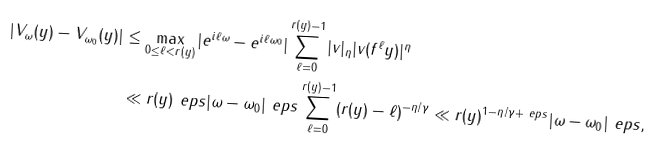<formula> <loc_0><loc_0><loc_500><loc_500>| V _ { \omega } ( y ) - V _ { \omega _ { 0 } } ( y ) | & \leq \max _ { 0 \leq \ell < r ( y ) } | e ^ { i \ell \omega } - e ^ { i \ell \omega _ { 0 } } | \sum _ { \ell = 0 } ^ { r ( y ) - 1 } | v | _ { \eta } | v ( f ^ { \ell } y ) | ^ { \eta } \\ & \ll r ( y ) ^ { \ } e p s | \omega - \omega _ { 0 } | ^ { \ } e p s \sum _ { \ell = 0 } ^ { r ( y ) - 1 } ( r ( y ) - \ell ) ^ { - \eta / \gamma } \ll r ( y ) ^ { 1 - \eta / \gamma + \ e p s } | \omega - \omega _ { 0 } | ^ { \ } e p s ,</formula> 